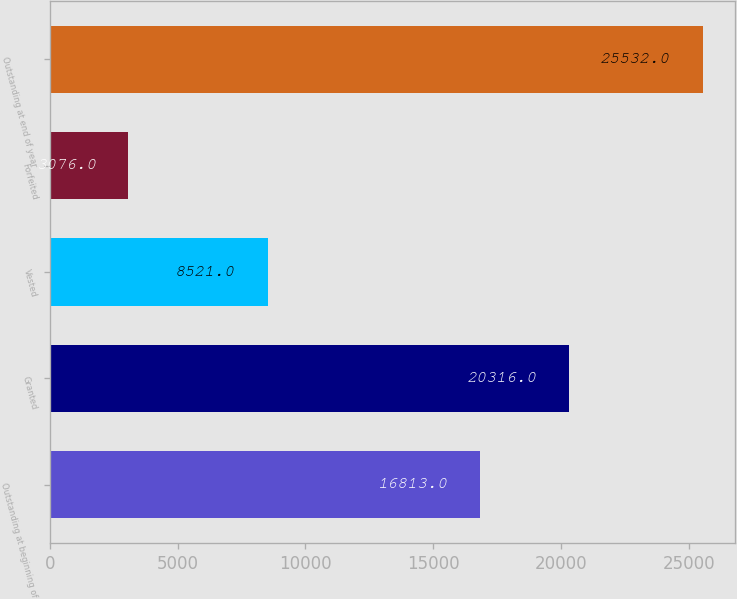Convert chart to OTSL. <chart><loc_0><loc_0><loc_500><loc_500><bar_chart><fcel>Outstanding at beginning of<fcel>Granted<fcel>Vested<fcel>Forfeited<fcel>Outstanding at end of year<nl><fcel>16813<fcel>20316<fcel>8521<fcel>3076<fcel>25532<nl></chart> 